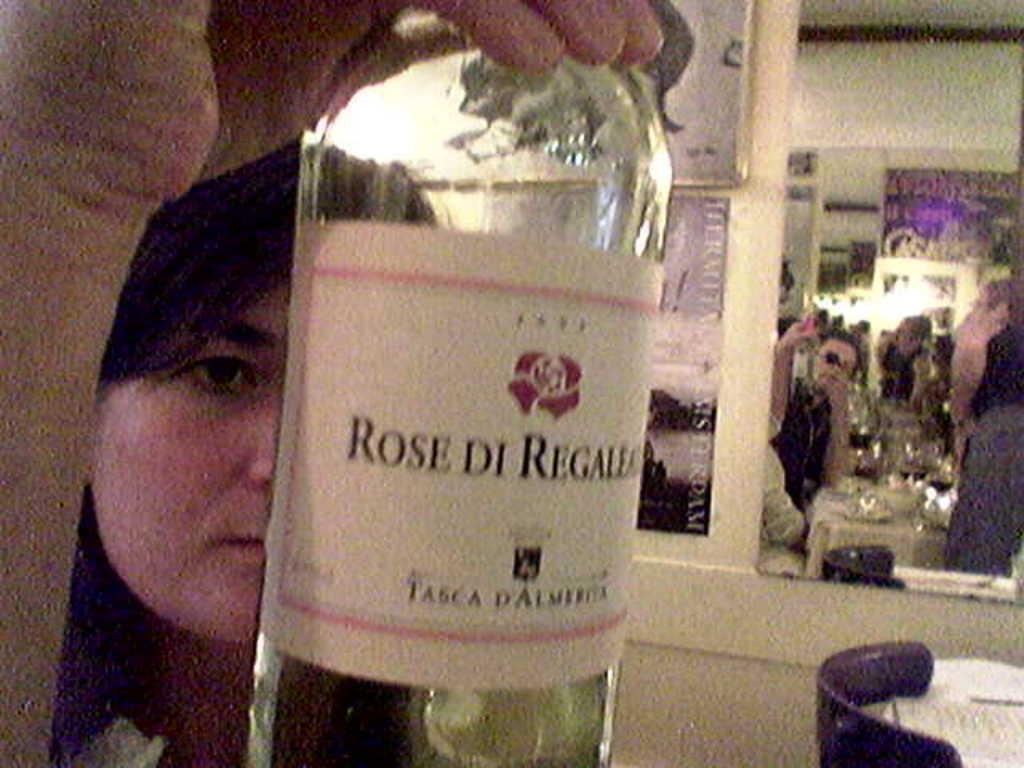What is the main subject of the image? There is a woman in the image. What is the woman holding in the image? The woman is holding a bottle. How many people are in the crowd surrounding the woman in the image? There is no crowd present in the image; it only features the woman holding a bottle. What type of rock is the woman using to open the bottle in the image? There is no rock present in the image, and the woman is not using any tool to open the bottle. 